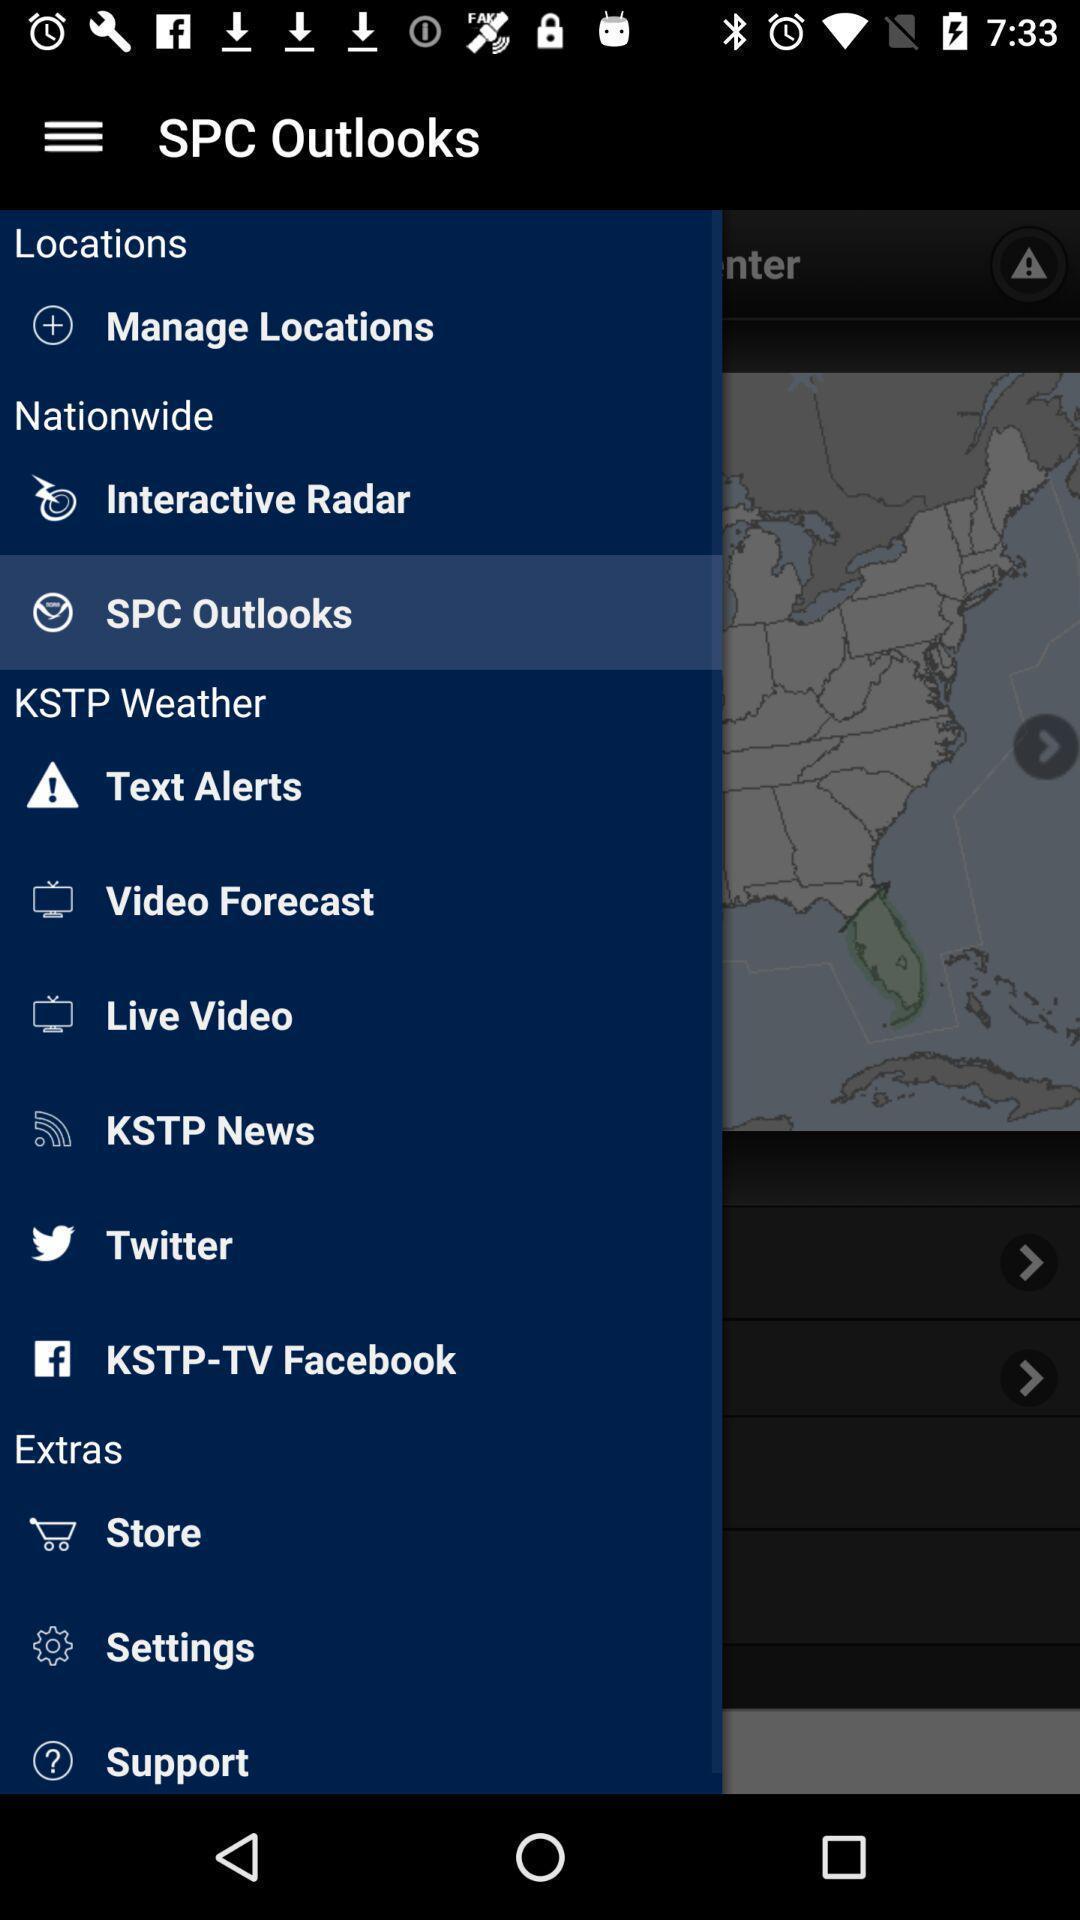What details can you identify in this image? Screen shows different options of spa outlooks. 